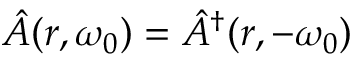Convert formula to latex. <formula><loc_0><loc_0><loc_500><loc_500>\hat { A } ( r , \omega _ { 0 } ) = \hat { A } ^ { \dagger } ( r , - \omega _ { 0 } )</formula> 